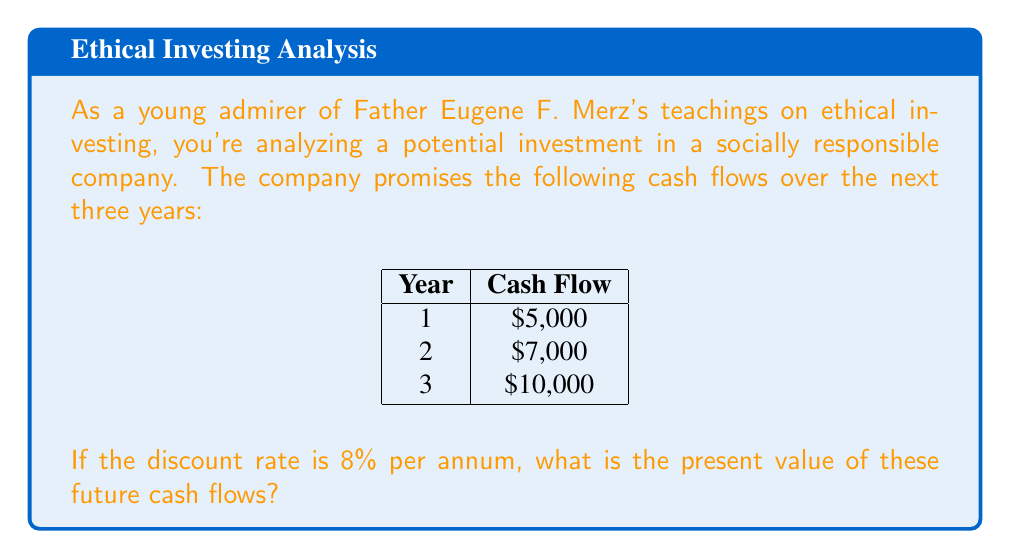Teach me how to tackle this problem. To calculate the present value of future cash flows, we use the discounted cash flow (DCF) analysis. The formula for the present value (PV) of a single cash flow is:

$$ PV = \frac{CF_t}{(1+r)^t} $$

Where:
$CF_t$ = Cash flow at time t
$r$ = Discount rate
$t$ = Time period

For multiple cash flows, we sum the present values:

$$ PV_{total} = \sum_{t=1}^n \frac{CF_t}{(1+r)^t} $$

Let's calculate the present value for each year:

Year 1: $PV_1 = \frac{5000}{(1+0.08)^1} = \frac{5000}{1.08} = 4629.63$

Year 2: $PV_2 = \frac{7000}{(1+0.08)^2} = \frac{7000}{1.1664} = 6001.37$

Year 3: $PV_3 = \frac{10000}{(1+0.08)^3} = \frac{10000}{1.259712} = 7938.44$

Now, we sum these present values:

$PV_{total} = 4629.63 + 6001.37 + 7938.44 = 18569.44$

Therefore, the present value of the future cash flows is $18,569.44.
Answer: $18,569.44 